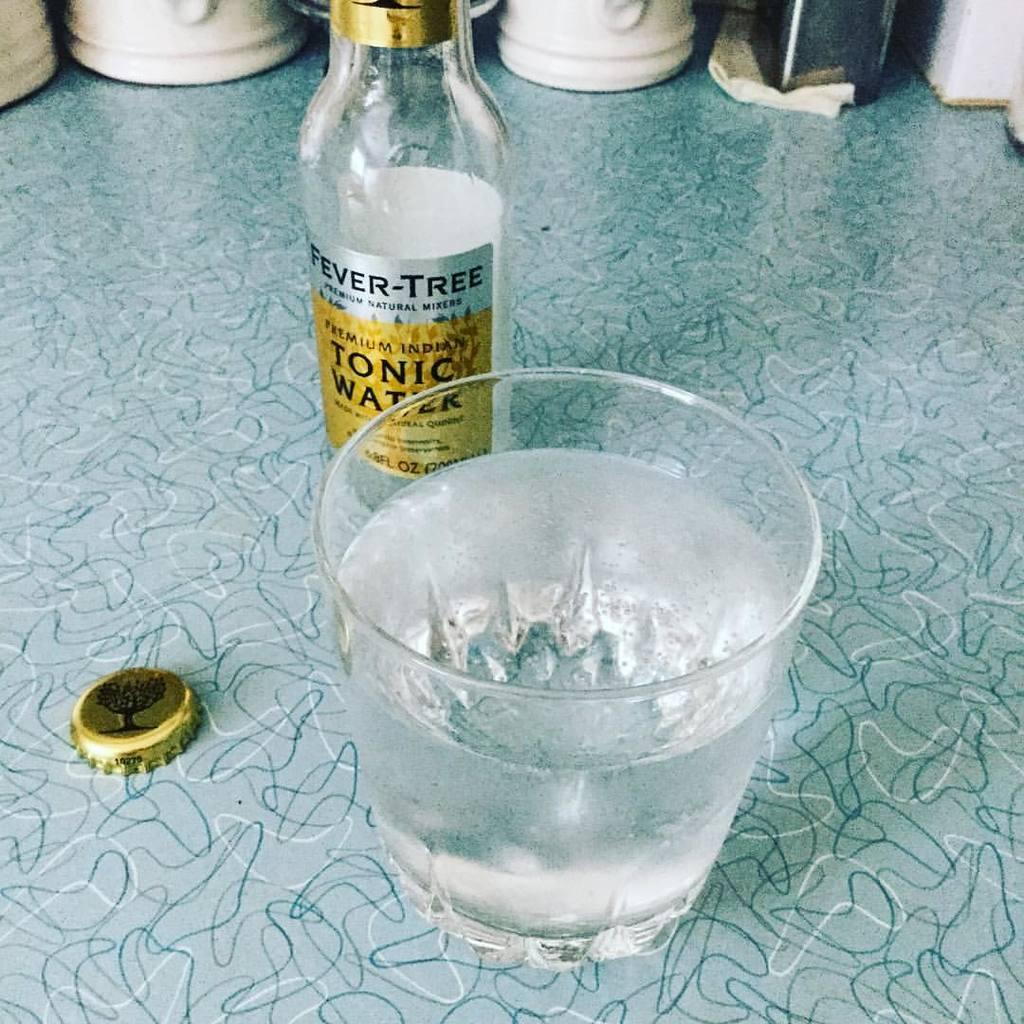What is one of the objects in the image? There is a bottle in the image. What is another object in the image? There is a glass in the image. Can you describe a small item related to the bottle? There is a bottle cap in the image. What type of railway can be seen in the image? There is no railway present in the image. How many toads are visible in the image? There are no toads present in the image. 